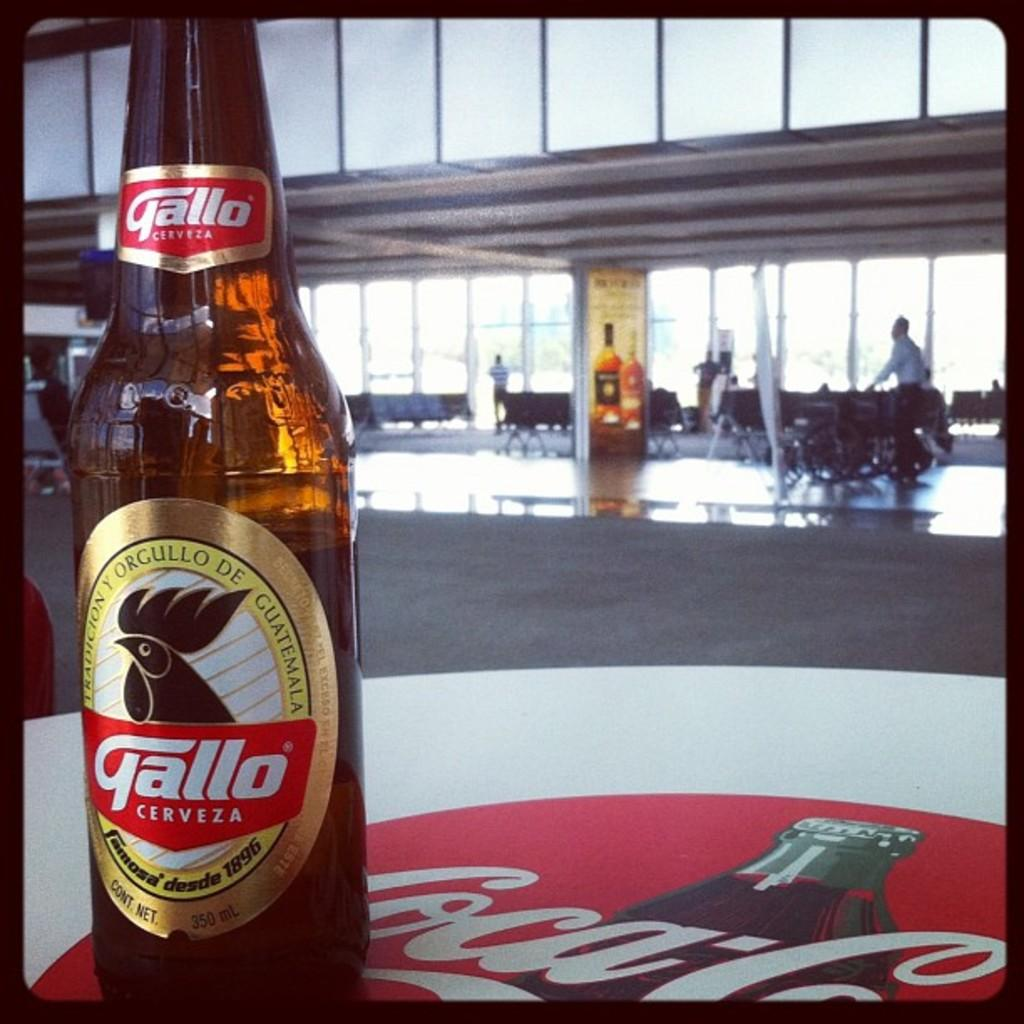<image>
Describe the image concisely. A Gallo beer sits atop a Coca-Cola logo on a table 